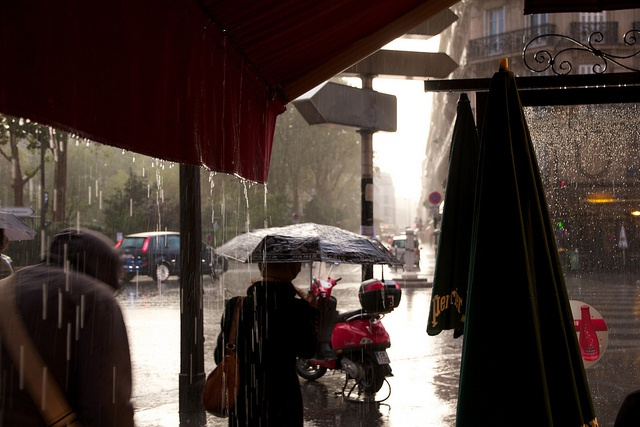Describe the objects in this image and their specific colors. I can see umbrella in black, maroon, and gray tones, people in black, gray, and maroon tones, people in black, maroon, and gray tones, motorcycle in black, maroon, gray, and darkgray tones, and umbrella in black, maroon, and brown tones in this image. 